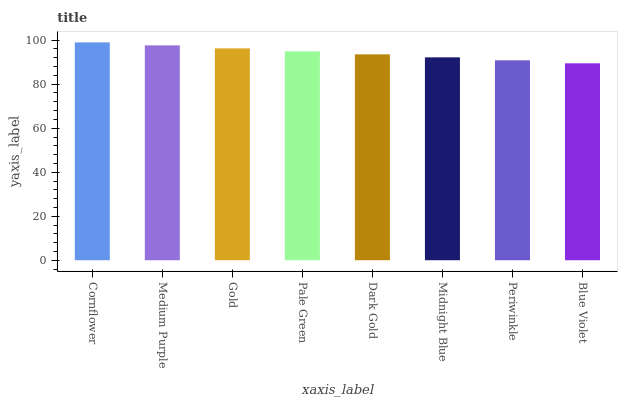Is Blue Violet the minimum?
Answer yes or no. Yes. Is Cornflower the maximum?
Answer yes or no. Yes. Is Medium Purple the minimum?
Answer yes or no. No. Is Medium Purple the maximum?
Answer yes or no. No. Is Cornflower greater than Medium Purple?
Answer yes or no. Yes. Is Medium Purple less than Cornflower?
Answer yes or no. Yes. Is Medium Purple greater than Cornflower?
Answer yes or no. No. Is Cornflower less than Medium Purple?
Answer yes or no. No. Is Pale Green the high median?
Answer yes or no. Yes. Is Dark Gold the low median?
Answer yes or no. Yes. Is Dark Gold the high median?
Answer yes or no. No. Is Gold the low median?
Answer yes or no. No. 